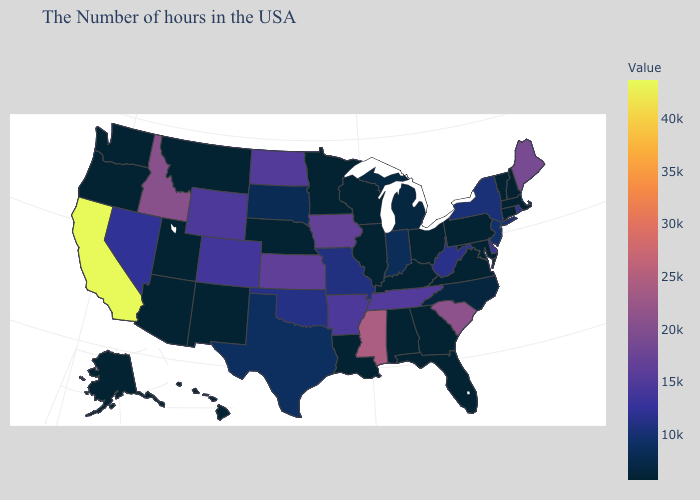Does Hawaii have the lowest value in the USA?
Quick response, please. Yes. Does Alaska have the lowest value in the West?
Answer briefly. Yes. Does Delaware have a higher value than Indiana?
Give a very brief answer. Yes. 